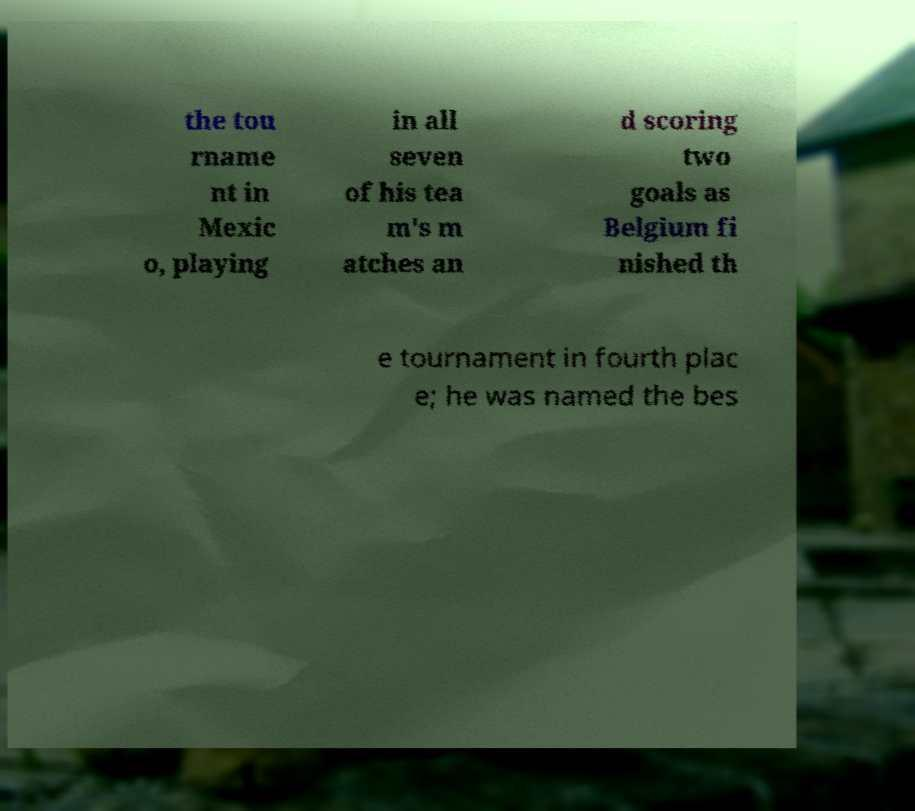Could you assist in decoding the text presented in this image and type it out clearly? the tou rname nt in Mexic o, playing in all seven of his tea m's m atches an d scoring two goals as Belgium fi nished th e tournament in fourth plac e; he was named the bes 